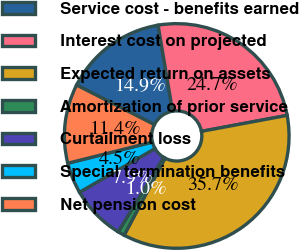<chart> <loc_0><loc_0><loc_500><loc_500><pie_chart><fcel>Service cost - benefits earned<fcel>Interest cost on projected<fcel>Expected return on assets<fcel>Amortization of prior service<fcel>Curtailment loss<fcel>Special termination benefits<fcel>Net pension cost<nl><fcel>14.86%<fcel>24.72%<fcel>35.69%<fcel>0.97%<fcel>7.92%<fcel>4.45%<fcel>11.39%<nl></chart> 